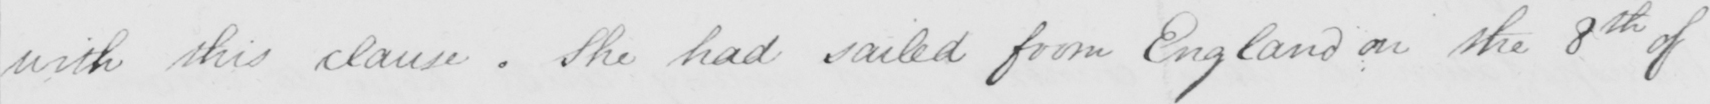Please transcribe the handwritten text in this image. with this clause . She had sailed from England on the 8th of 